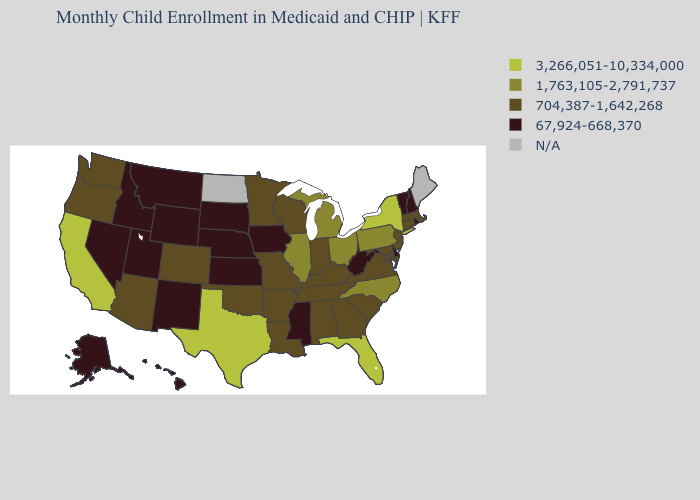What is the value of Alaska?
Be succinct. 67,924-668,370. Name the states that have a value in the range 3,266,051-10,334,000?
Write a very short answer. California, Florida, New York, Texas. What is the value of Colorado?
Short answer required. 704,387-1,642,268. What is the lowest value in the USA?
Write a very short answer. 67,924-668,370. Is the legend a continuous bar?
Concise answer only. No. Name the states that have a value in the range N/A?
Give a very brief answer. Maine, North Dakota. How many symbols are there in the legend?
Be succinct. 5. Which states have the lowest value in the USA?
Quick response, please. Alaska, Delaware, Hawaii, Idaho, Iowa, Kansas, Mississippi, Montana, Nebraska, Nevada, New Hampshire, New Mexico, Rhode Island, South Dakota, Utah, Vermont, West Virginia, Wyoming. Name the states that have a value in the range 67,924-668,370?
Give a very brief answer. Alaska, Delaware, Hawaii, Idaho, Iowa, Kansas, Mississippi, Montana, Nebraska, Nevada, New Hampshire, New Mexico, Rhode Island, South Dakota, Utah, Vermont, West Virginia, Wyoming. Among the states that border Utah , does Colorado have the lowest value?
Short answer required. No. Does the first symbol in the legend represent the smallest category?
Answer briefly. No. Does Mississippi have the lowest value in the USA?
Be succinct. Yes. What is the highest value in the MidWest ?
Give a very brief answer. 1,763,105-2,791,737. Does Ohio have the lowest value in the USA?
Concise answer only. No. 